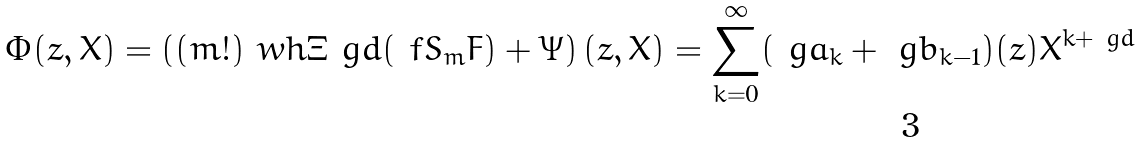Convert formula to latex. <formula><loc_0><loc_0><loc_500><loc_500>\Phi ( z , X ) = \left ( ( m ! ) \ w h { \Xi } _ { \ } g d ( \ f S _ { m } F ) + \Psi \right ) ( z , X ) = \sum ^ { \infty } _ { k = 0 } ( \ g a _ { k } + \ g b _ { k - 1 } ) ( z ) X ^ { k + \ g d }</formula> 